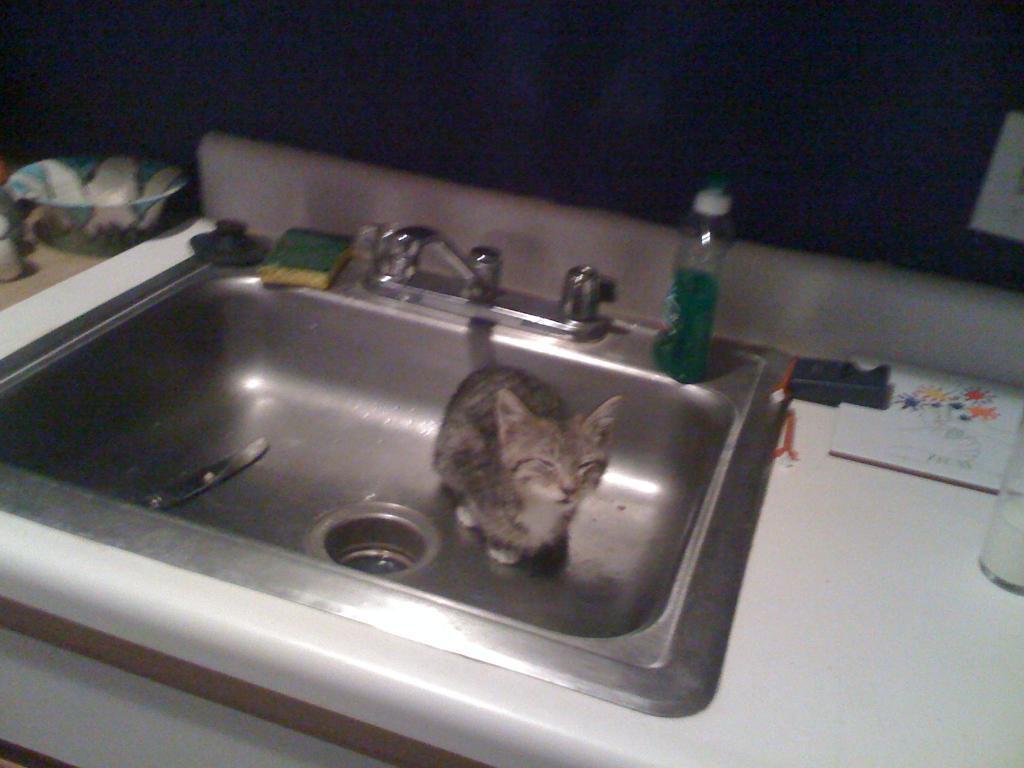Could you give a brief overview of what you see in this image? In this image there is a cat in the sink. Top of the sink there is a tap, bottle, scrub pad are on it. Beside sink there is a bowl. Right side there is a glass. 